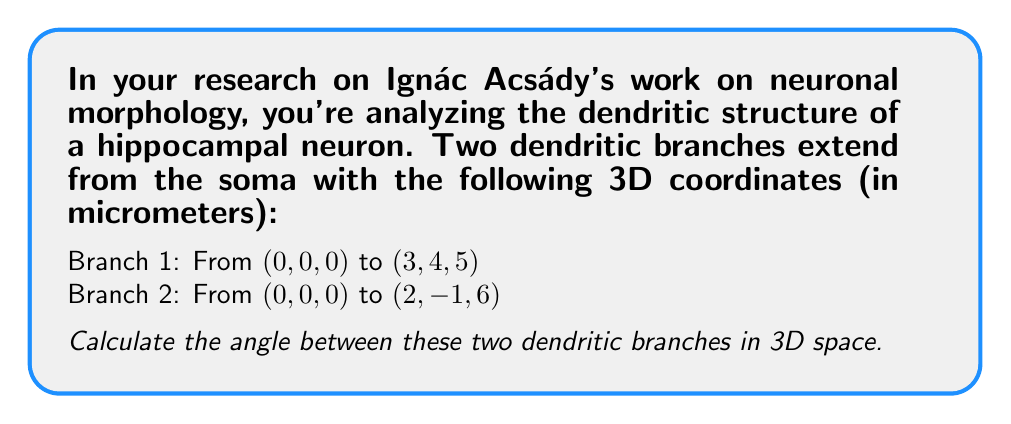Give your solution to this math problem. To find the angle between two vectors in 3D space, we can use the dot product formula:

$$\cos \theta = \frac{\vec{a} \cdot \vec{b}}{|\vec{a}||\vec{b}|}$$

Where $\vec{a}$ and $\vec{b}$ are the vectors representing the dendritic branches, and $\theta$ is the angle between them.

Step 1: Determine the vectors
$\vec{a} = (3, 4, 5)$
$\vec{b} = (2, -1, 6)$

Step 2: Calculate the dot product $\vec{a} \cdot \vec{b}$
$$\vec{a} \cdot \vec{b} = (3)(2) + (4)(-1) + (5)(6) = 6 - 4 + 30 = 32$$

Step 3: Calculate the magnitudes of the vectors
$$|\vec{a}| = \sqrt{3^2 + 4^2 + 5^2} = \sqrt{50}$$
$$|\vec{b}| = \sqrt{2^2 + (-1)^2 + 6^2} = \sqrt{41}$$

Step 4: Apply the dot product formula
$$\cos \theta = \frac{32}{\sqrt{50}\sqrt{41}}$$

Step 5: Calculate the angle using the inverse cosine function
$$\theta = \arccos\left(\frac{32}{\sqrt{50}\sqrt{41}}\right)$$

Step 6: Convert to degrees
$$\theta = \arccos\left(\frac{32}{\sqrt{50}\sqrt{41}}\right) \cdot \frac{180°}{\pi}$$
Answer: $\theta \approx 27.35°$ 